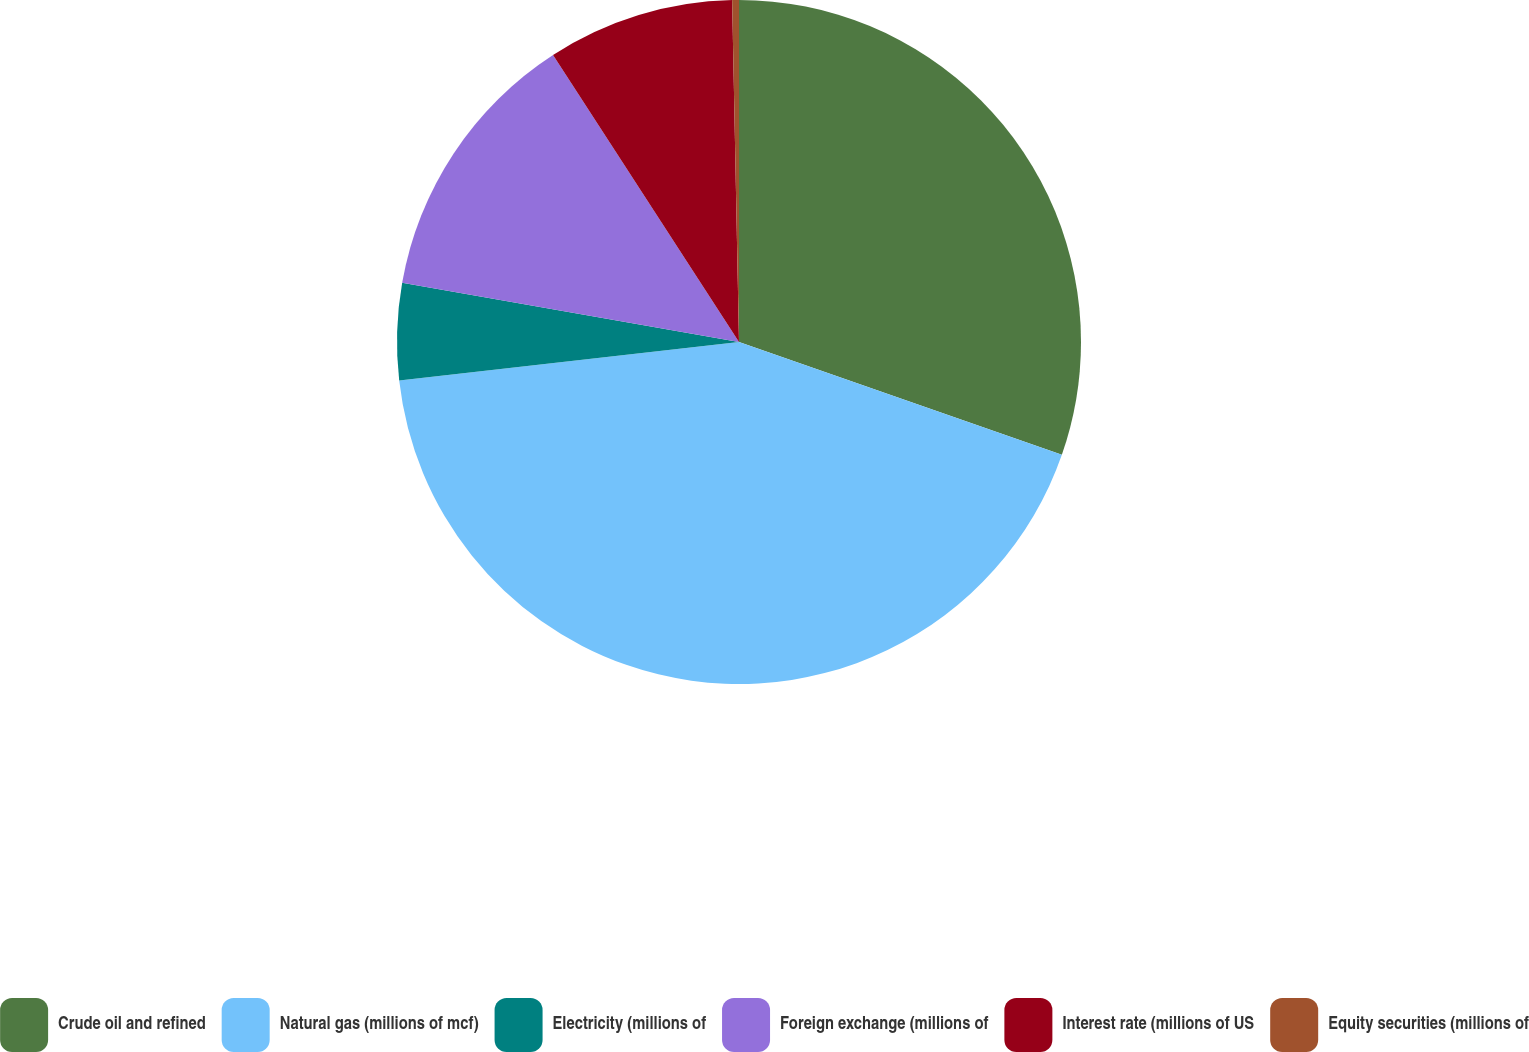Convert chart to OTSL. <chart><loc_0><loc_0><loc_500><loc_500><pie_chart><fcel>Crude oil and refined<fcel>Natural gas (millions of mcf)<fcel>Electricity (millions of<fcel>Foreign exchange (millions of<fcel>Interest rate (millions of US<fcel>Equity securities (millions of<nl><fcel>30.35%<fcel>42.85%<fcel>4.57%<fcel>13.08%<fcel>8.83%<fcel>0.32%<nl></chart> 